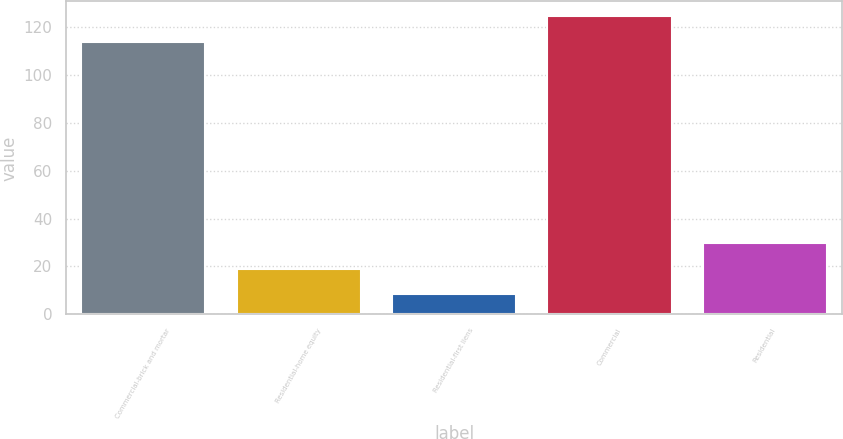<chart> <loc_0><loc_0><loc_500><loc_500><bar_chart><fcel>Commercial-brick and mortar<fcel>Residential-home equity<fcel>Residential-first liens<fcel>Commercial<fcel>Residential<nl><fcel>114<fcel>19.08<fcel>8.5<fcel>124.58<fcel>29.66<nl></chart> 